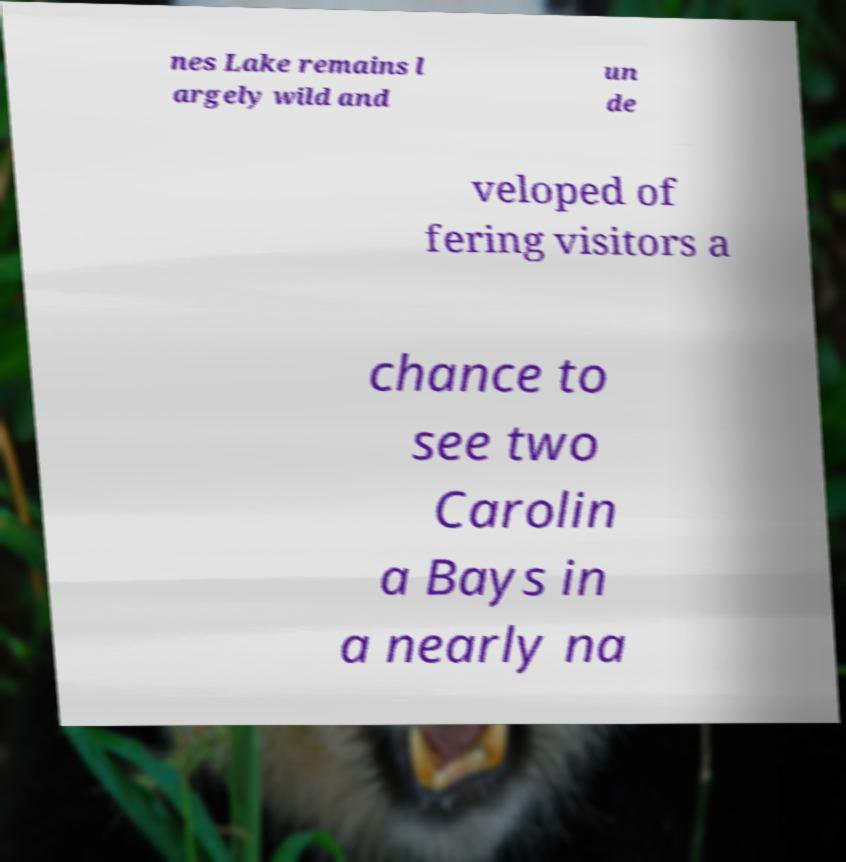Can you accurately transcribe the text from the provided image for me? nes Lake remains l argely wild and un de veloped of fering visitors a chance to see two Carolin a Bays in a nearly na 